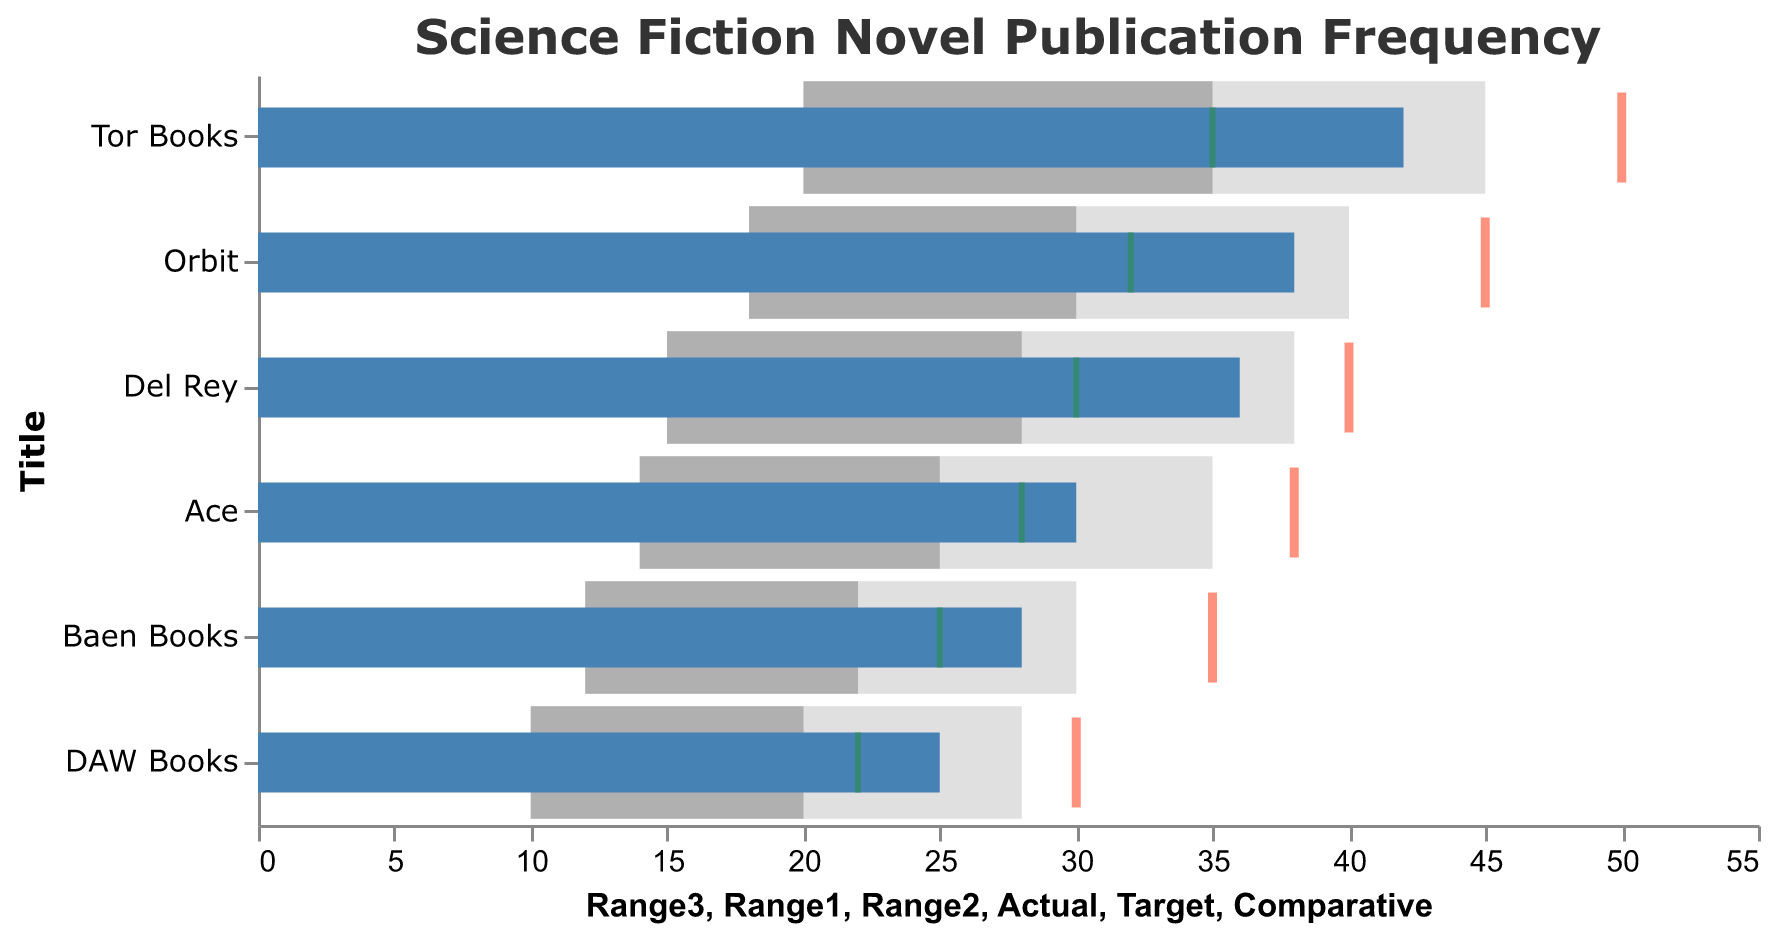what is the title of the figure? The title can be found at the top of the figure, normally displayed in a larger font and bold text. The title provides a succinct description of the figure's content.
Answer: Science Fiction Novel Publication Frequency Which publishing house has the highest actual publication frequency? By observing the blue bars, which represent actual publication frequencies, the publishing house with the longest blue bar corresponds to the highest actual publication frequency.
Answer: Tor Books What is the target publication number for Orbit? The target publication number can be identified by the red tick mark for Orbit, which is positioned along the x-axis.
Answer: 45 What is the difference between the actual and comparative values for Del Rey? Subtract the comparative value (green tick) for Del Rey from its actual value (blue bar). 36 (actual) - 30 (comparative) = 6
Answer: 6 Which publishing houses have actual publication frequencies below 30? Identify the publishing houses whose actual publication frequencies (blue bars) extend below the 30 mark on the x-axis.
Answer: Baen Books, DAW Books What is the comparative publication frequency for Ace? Check the position of the green tick mark for Ace, which indicates the comparative publication frequency along the x-axis.
Answer: 28 How does Tor Books compare to its target? Observe the blue bar (actual) and the red tick (target). Tor Books' actual publication frequency is less than its target since the blue bar stops at 42, while the red tick is at 50.
Answer: 8 less than target Which publishing house has the smallest range for publication frequencies? The range is the difference between Range1 and Range3. Compare these values for all publishing houses. DAW Books has Range1 = 10 and Range3 = 28, so the range is 18, which is the smallest.
Answer: DAW Books What is the average actual publication frequency of all the publishing houses? Sum the actual publication frequencies of all the publishing houses and divide by the number of publishing houses. (42 + 38 + 36 + 28 + 25 + 30) / 6 = 199 / 6 ≈ 33.17
Answer: 33.17 How many publishing houses have actual publications exceeding their comparative values? Compare the length of each blue bar (actual) with its corresponding green tick (comparative). If the blue bar extends further than the green tick, count it. There are four such publishing houses: Tor Books, Orbit, Del Rey, and Ace.
Answer: 4 